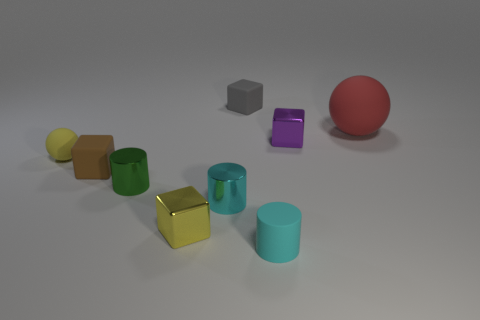Add 1 purple metallic cubes. How many objects exist? 10 Subtract all cylinders. How many objects are left? 6 Subtract all gray things. Subtract all matte spheres. How many objects are left? 6 Add 2 yellow rubber things. How many yellow rubber things are left? 3 Add 6 small gray blocks. How many small gray blocks exist? 7 Subtract 0 green blocks. How many objects are left? 9 